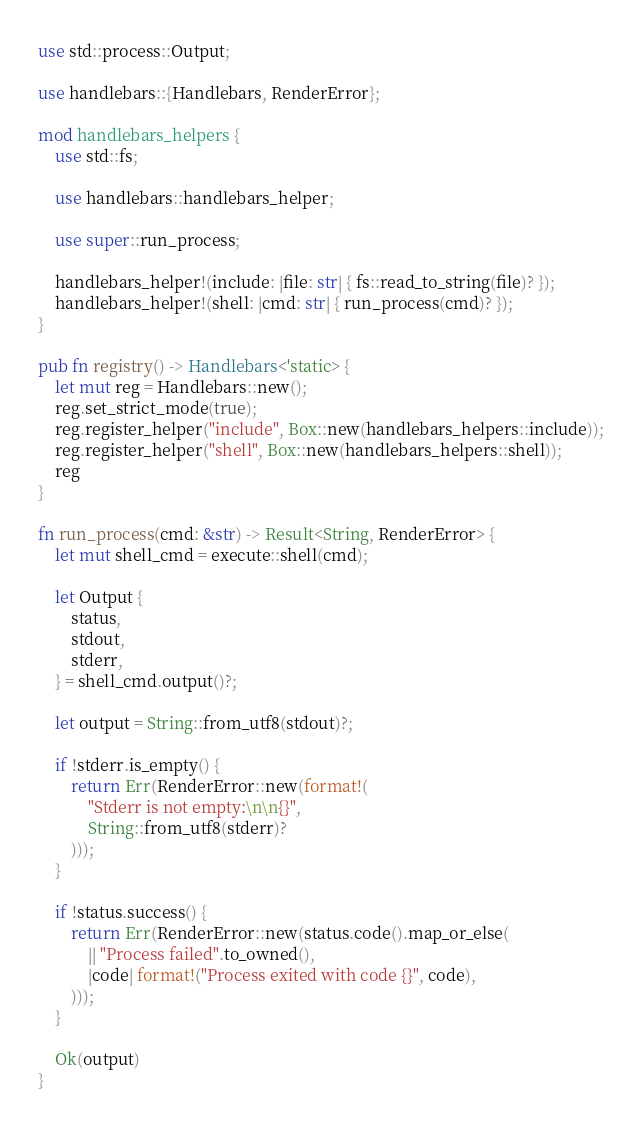Convert code to text. <code><loc_0><loc_0><loc_500><loc_500><_Rust_>use std::process::Output;

use handlebars::{Handlebars, RenderError};

mod handlebars_helpers {
    use std::fs;

    use handlebars::handlebars_helper;

    use super::run_process;

    handlebars_helper!(include: |file: str| { fs::read_to_string(file)? });
    handlebars_helper!(shell: |cmd: str| { run_process(cmd)? });
}

pub fn registry() -> Handlebars<'static> {
    let mut reg = Handlebars::new();
    reg.set_strict_mode(true);
    reg.register_helper("include", Box::new(handlebars_helpers::include));
    reg.register_helper("shell", Box::new(handlebars_helpers::shell));
    reg
}

fn run_process(cmd: &str) -> Result<String, RenderError> {
    let mut shell_cmd = execute::shell(cmd);

    let Output {
        status,
        stdout,
        stderr,
    } = shell_cmd.output()?;

    let output = String::from_utf8(stdout)?;

    if !stderr.is_empty() {
        return Err(RenderError::new(format!(
            "Stderr is not empty:\n\n{}",
            String::from_utf8(stderr)?
        )));
    }

    if !status.success() {
        return Err(RenderError::new(status.code().map_or_else(
            || "Process failed".to_owned(),
            |code| format!("Process exited with code {}", code),
        )));
    }

    Ok(output)
}
</code> 